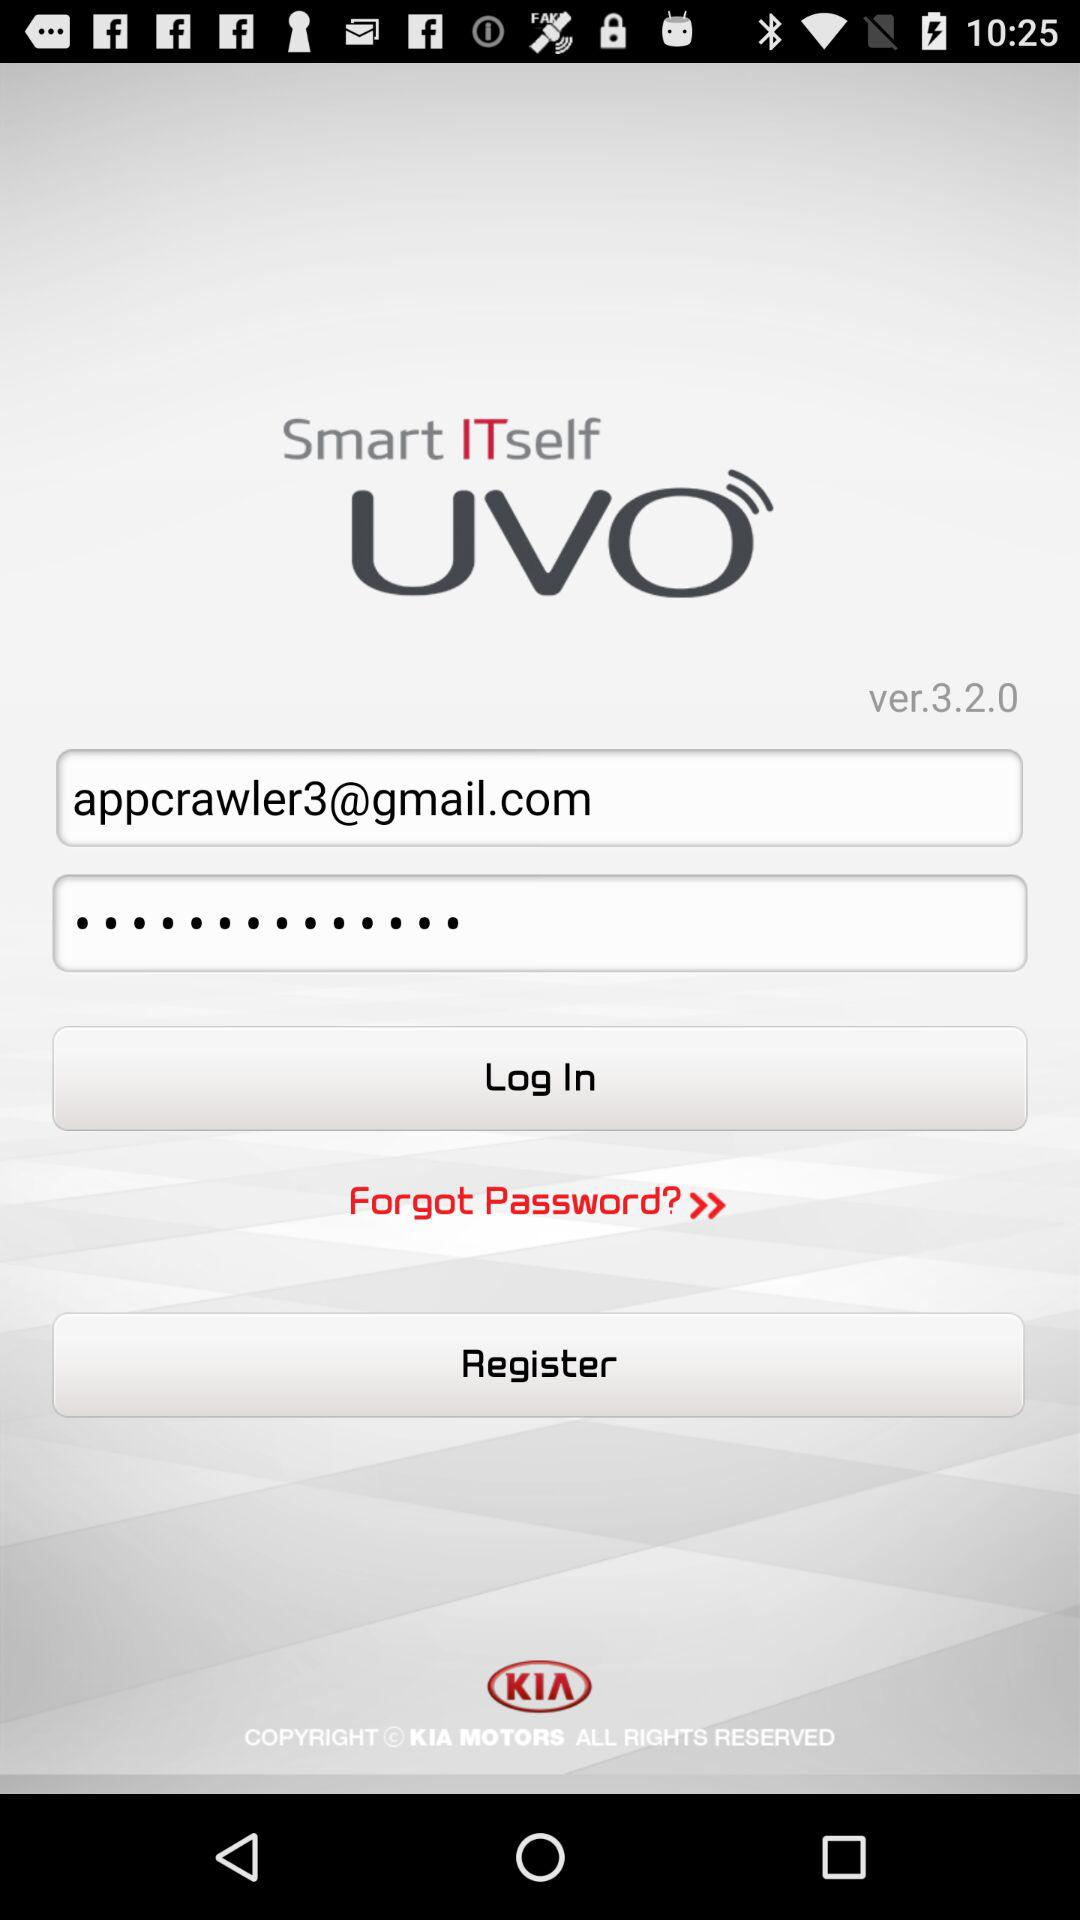What is the application name? The application name is "Smart ITself UVO". 